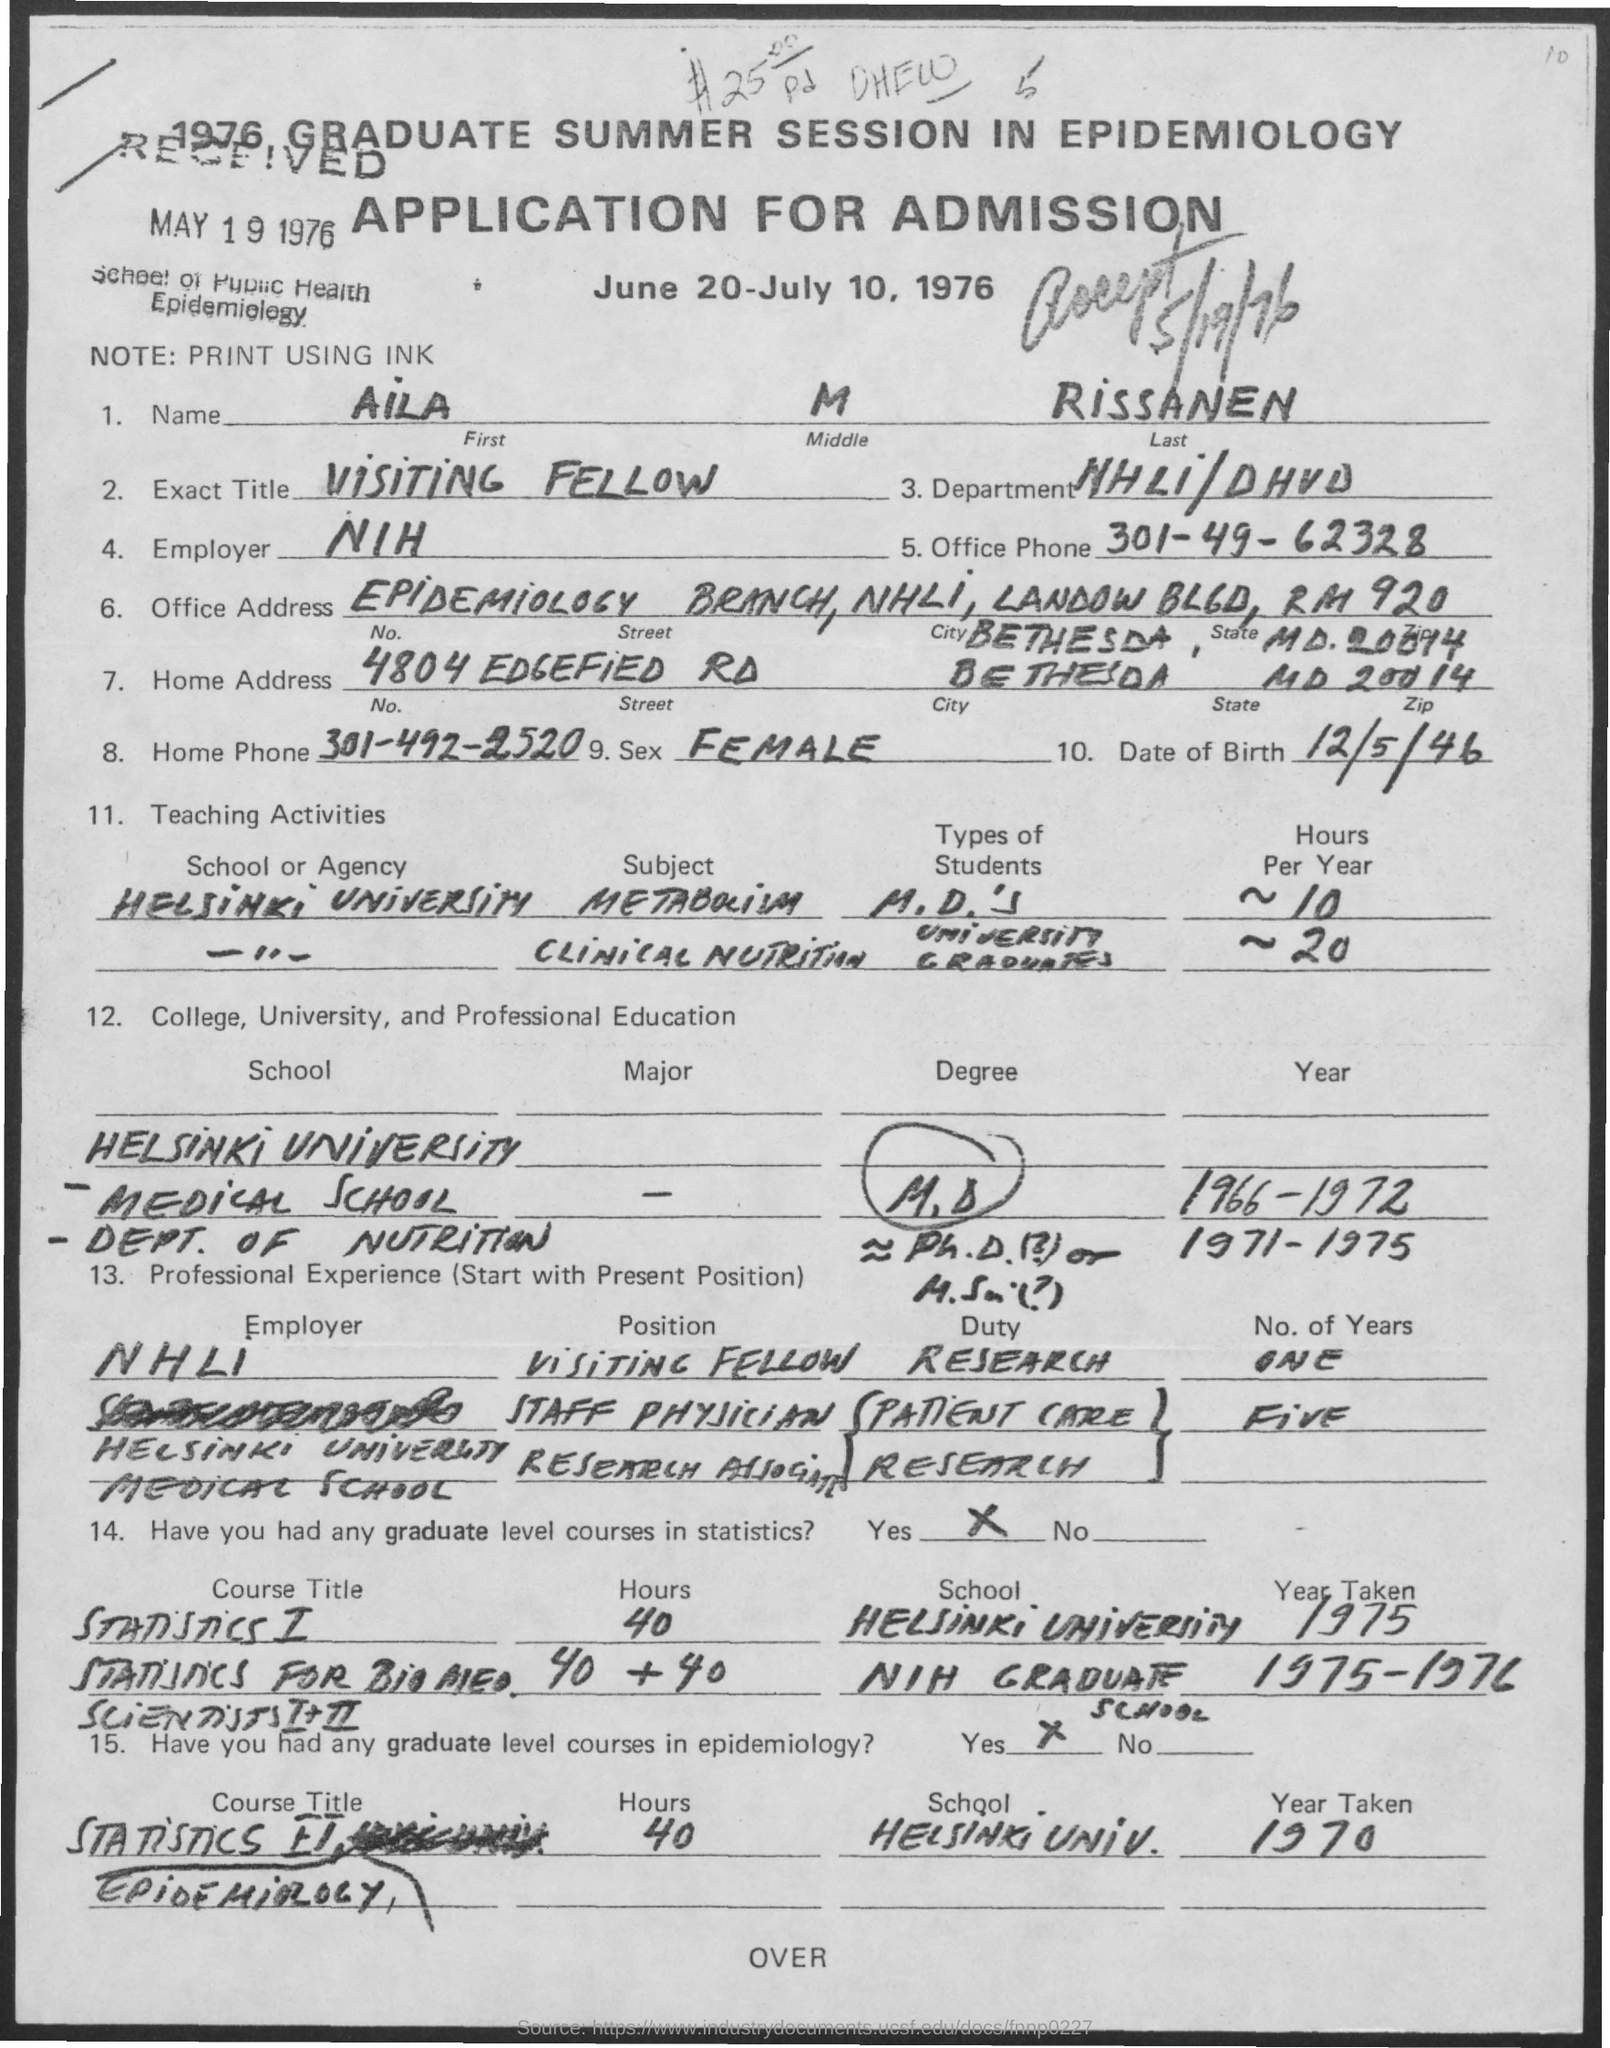What is the First Name?
Make the answer very short. Aila. What is the Middle Name?
Offer a very short reply. M. What is the Last Name?
Offer a very short reply. RISSANEN. Who is the Employer?
Provide a succinct answer. NIH. What is the Office Phone?
Make the answer very short. 301-49-62328. What is the City?
Provide a succinct answer. BETHESDA. 